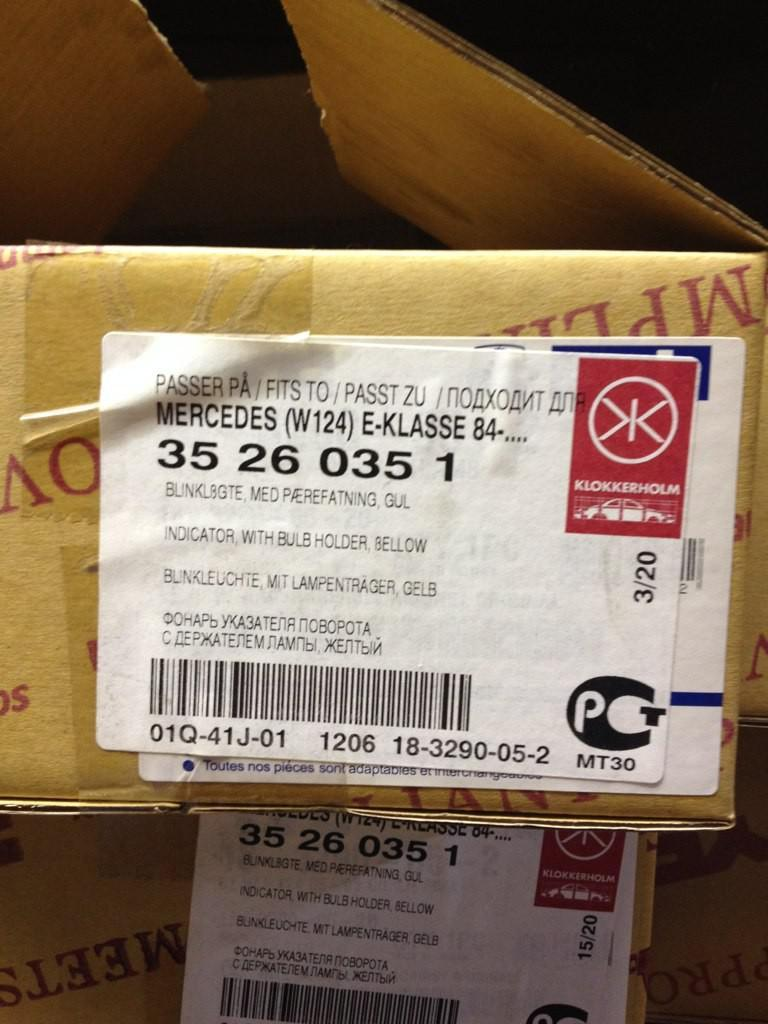<image>
Offer a succinct explanation of the picture presented. A package that has been mailed and has Mercedes on it. 